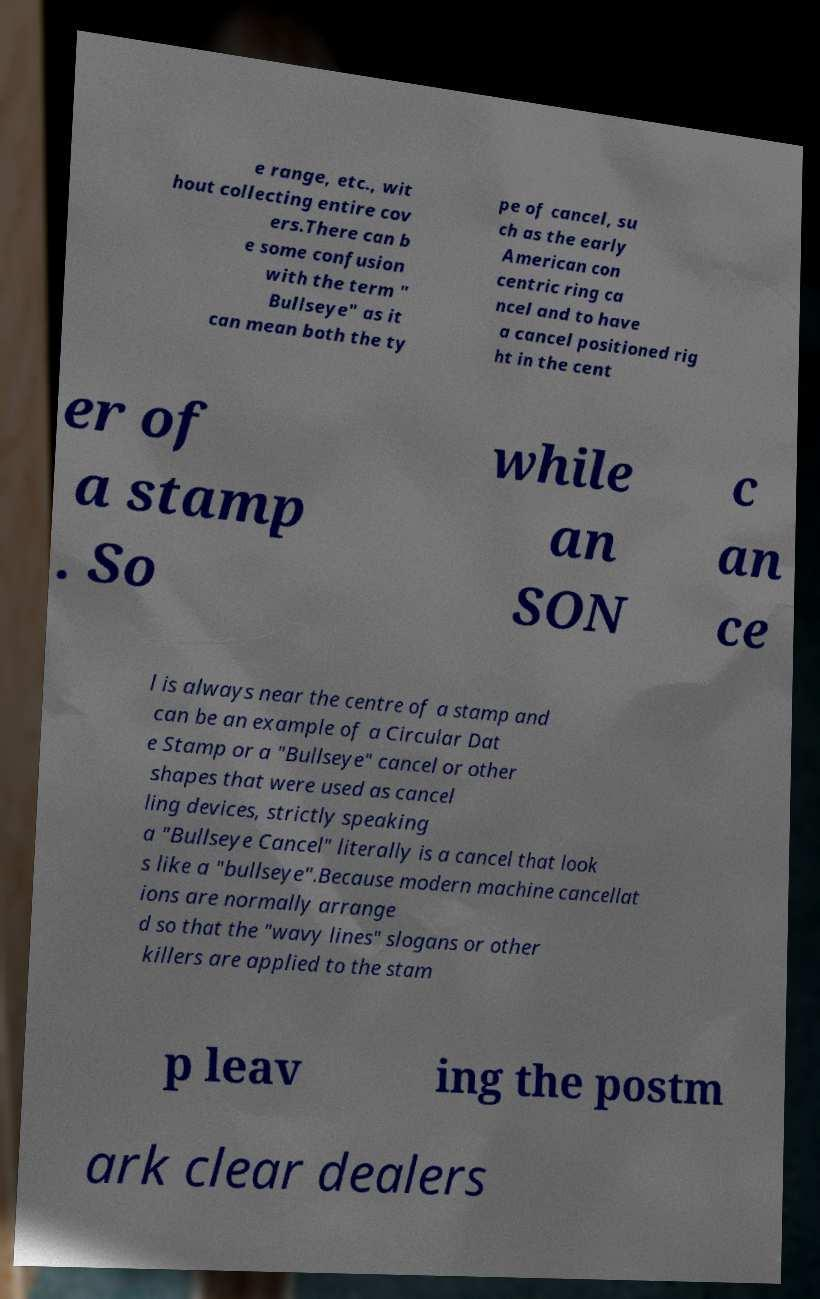Can you read and provide the text displayed in the image?This photo seems to have some interesting text. Can you extract and type it out for me? e range, etc., wit hout collecting entire cov ers.There can b e some confusion with the term " Bullseye" as it can mean both the ty pe of cancel, su ch as the early American con centric ring ca ncel and to have a cancel positioned rig ht in the cent er of a stamp . So while an SON c an ce l is always near the centre of a stamp and can be an example of a Circular Dat e Stamp or a "Bullseye" cancel or other shapes that were used as cancel ling devices, strictly speaking a "Bullseye Cancel" literally is a cancel that look s like a "bullseye".Because modern machine cancellat ions are normally arrange d so that the "wavy lines" slogans or other killers are applied to the stam p leav ing the postm ark clear dealers 